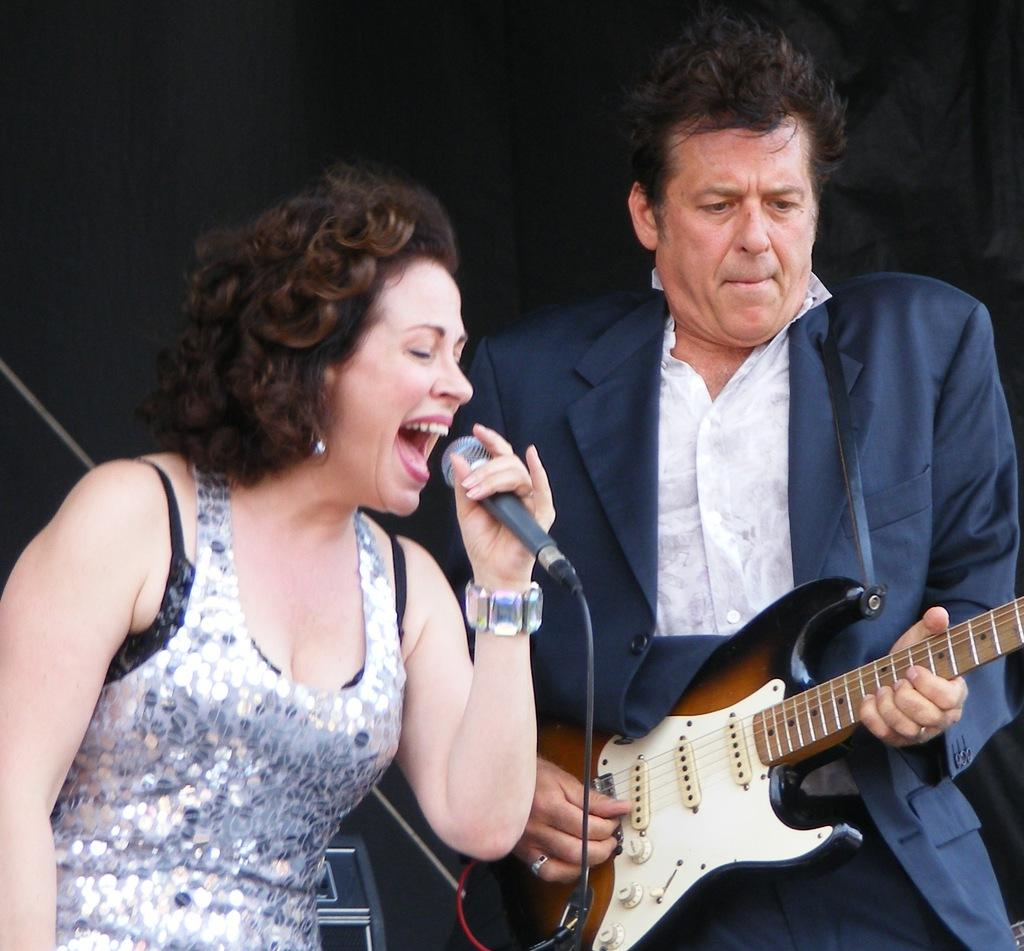How many people are in the image? There are two people in the image. Can you describe the gender of each person? One of the people is a man, and the other person is a woman. What is the man holding in the image? The man is holding a guitar. What is the man doing with the guitar? The man is playing the guitar. What is the woman holding in the image? The woman is holding a microphone. What is the woman doing with the microphone? The woman is singing. What type of mint can be seen growing near the man in the image? There is no mint visible in the image. 